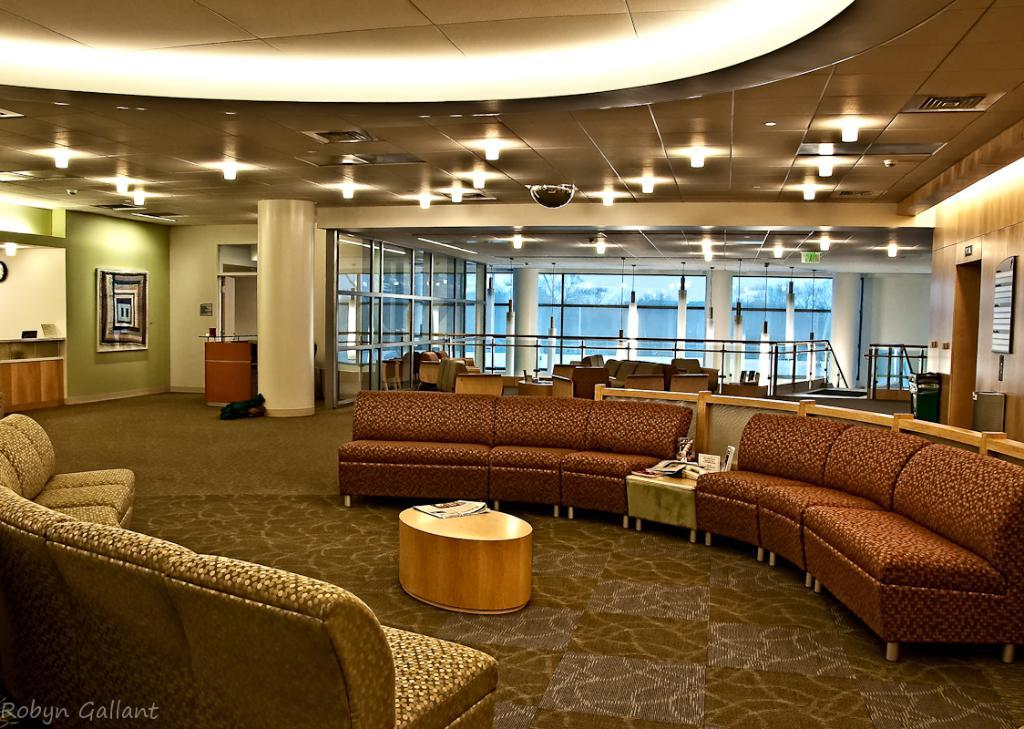What type of furniture is placed on the floor in the image? There is a sofa set on the floor in the image. What is positioned in front of the sofa set? There is a table in front of the sofa set. What type of seating is located at the back? There are chairs at the back. What can be seen on the walls in the image? There is a wall visible in the image. What is providing illumination in the image? There are lights visible in the image. What type of spade is being used to dig in the image? There is no spade present in the image; it features a sofa set, table, chairs, walls, and lights. What stage of development is the project in, as seen in the image? There is no project or development visible in the image; it shows a room with furniture and lighting. 